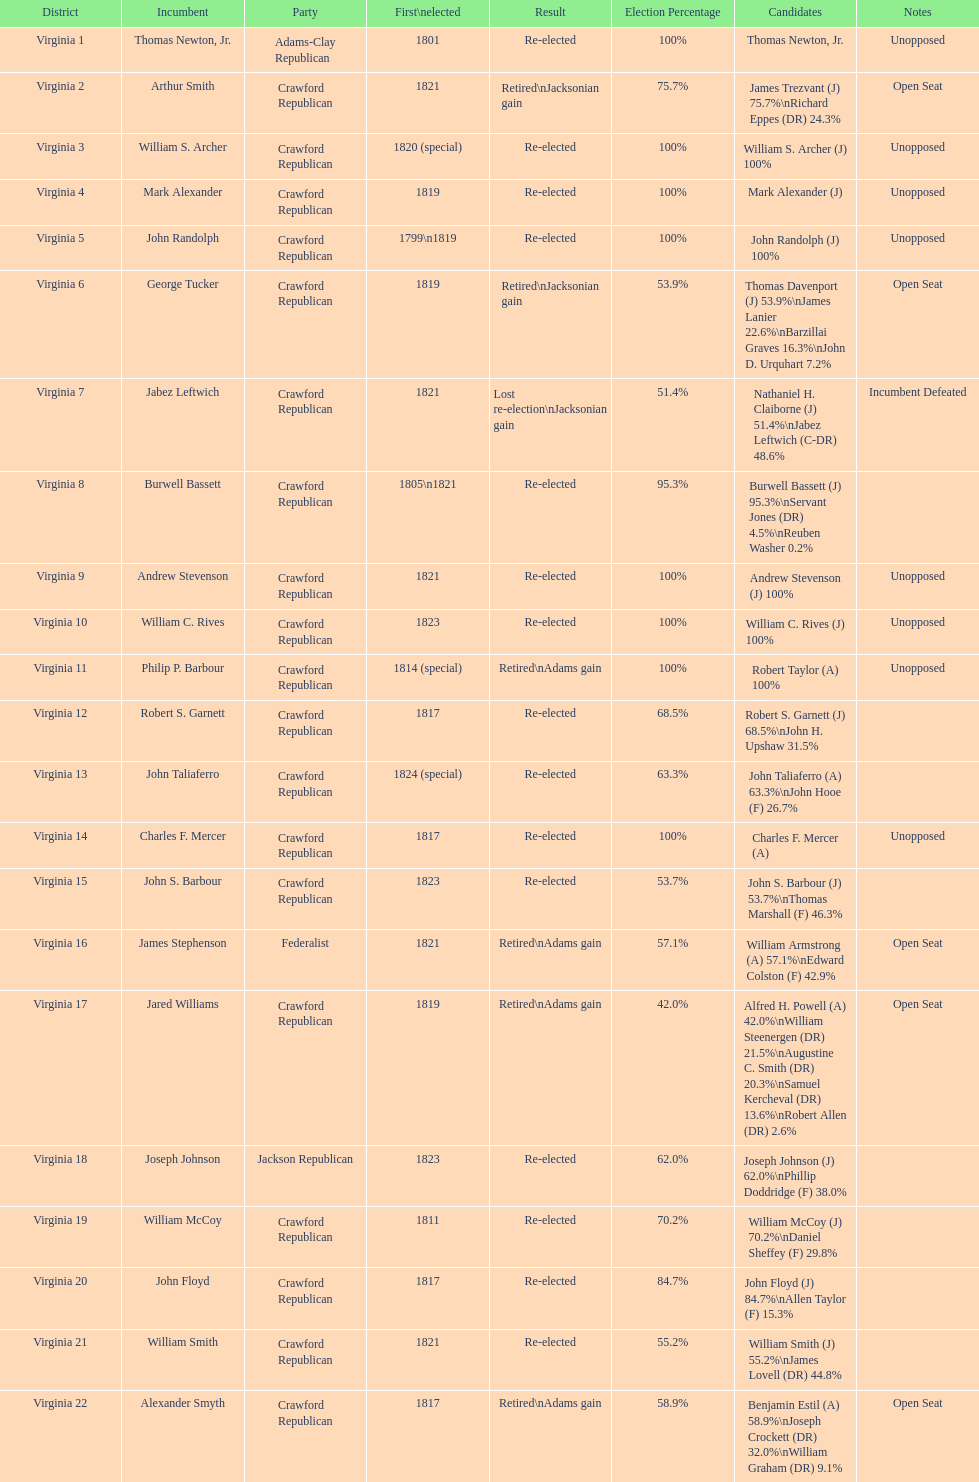Which jacksonian candidates got at least 76% of the vote in their races? Arthur Smith. 